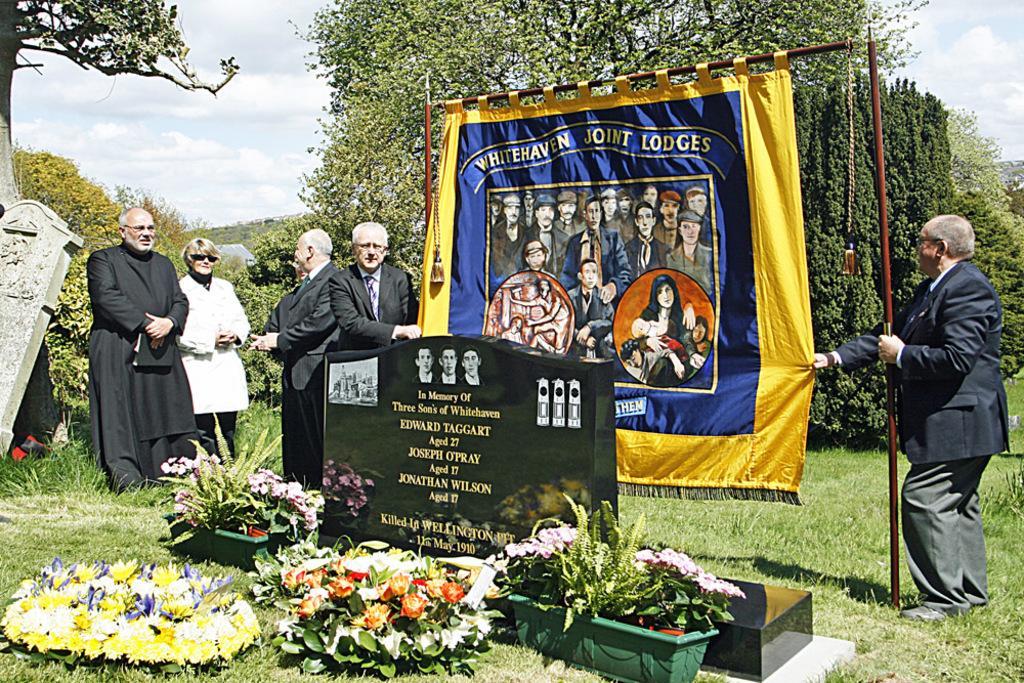Describe this image in one or two sentences. At the bottom of the image there are some plants and flowers and there is a graveyard. Behind them few people are standing and holding sticks, on the sticks there is a banner. Behind them there are some trees and clouds and sky. 